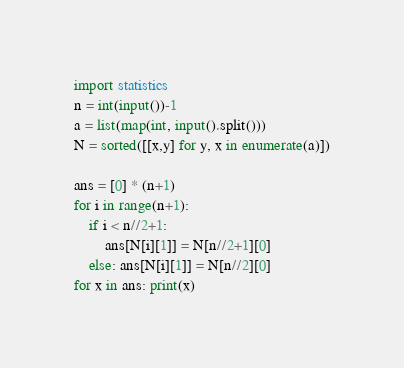<code> <loc_0><loc_0><loc_500><loc_500><_Python_>import statistics
n = int(input())-1
a = list(map(int, input().split()))
N = sorted([[x,y] for y, x in enumerate(a)])

ans = [0] * (n+1)
for i in range(n+1):
    if i < n//2+1: 
        ans[N[i][1]] = N[n//2+1][0]
    else: ans[N[i][1]] = N[n//2][0]
for x in ans: print(x)</code> 